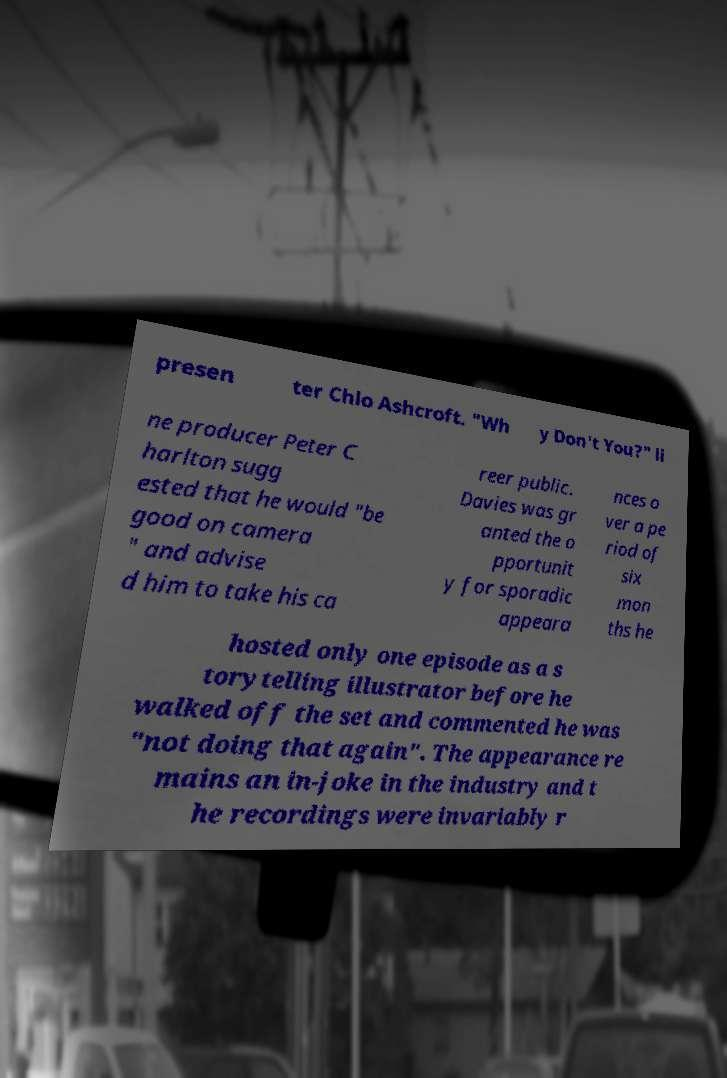Could you assist in decoding the text presented in this image and type it out clearly? presen ter Chlo Ashcroft. "Wh y Don't You?" li ne producer Peter C harlton sugg ested that he would "be good on camera " and advise d him to take his ca reer public. Davies was gr anted the o pportunit y for sporadic appeara nces o ver a pe riod of six mon ths he hosted only one episode as a s torytelling illustrator before he walked off the set and commented he was "not doing that again". The appearance re mains an in-joke in the industry and t he recordings were invariably r 